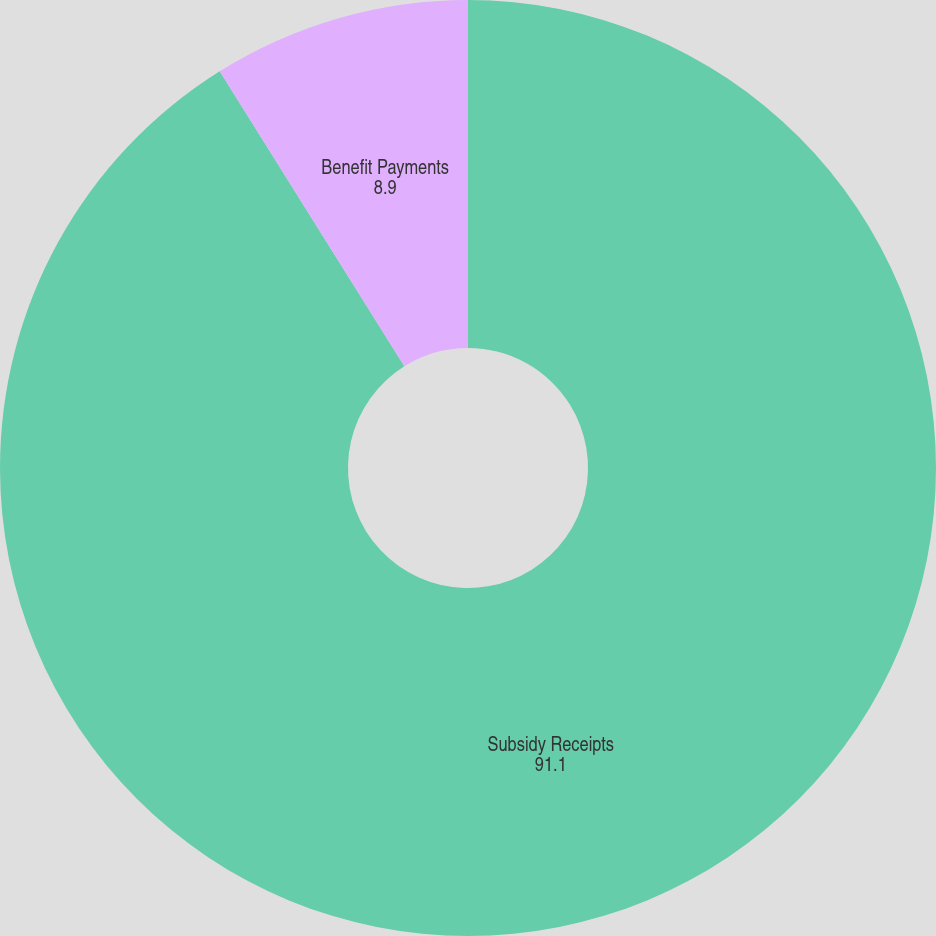Convert chart. <chart><loc_0><loc_0><loc_500><loc_500><pie_chart><fcel>Subsidy Receipts<fcel>Benefit Payments<nl><fcel>91.1%<fcel>8.9%<nl></chart> 